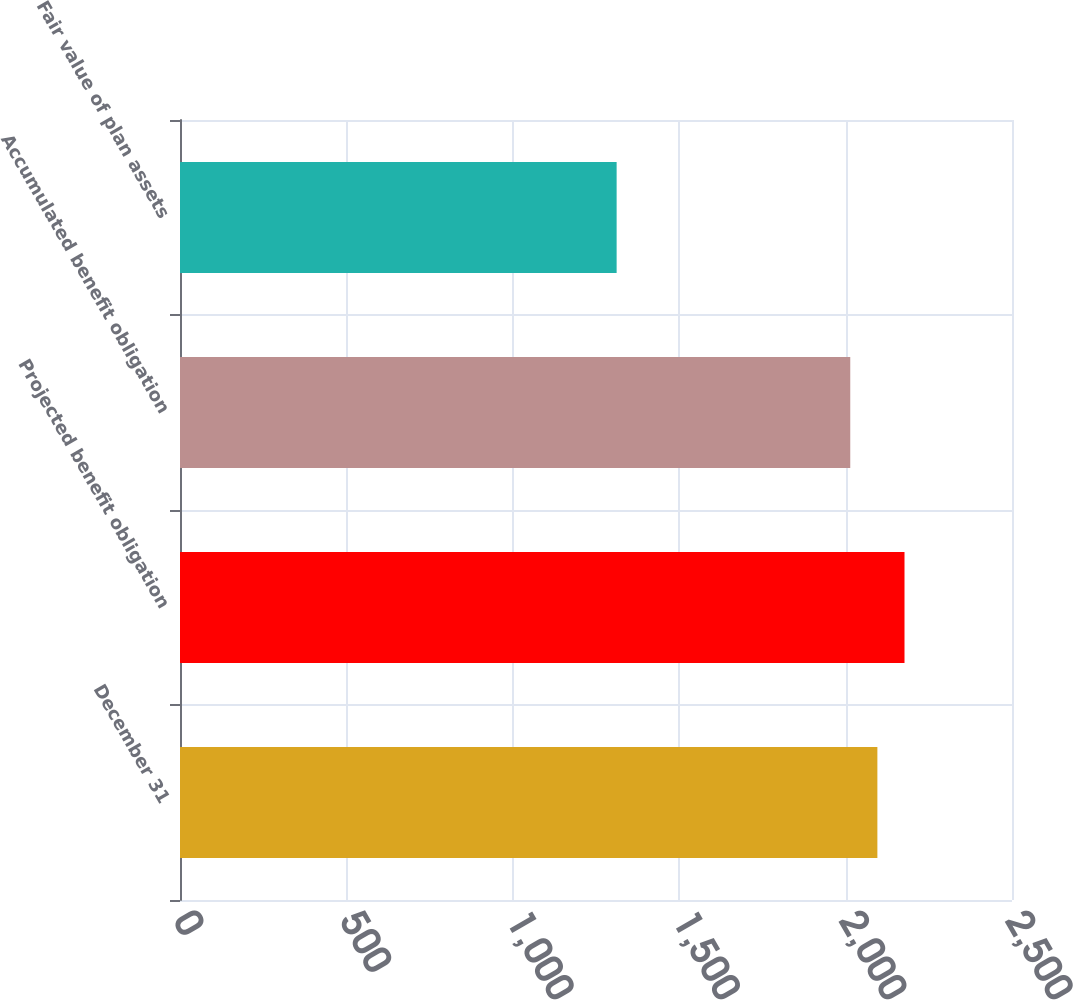Convert chart to OTSL. <chart><loc_0><loc_0><loc_500><loc_500><bar_chart><fcel>December 31<fcel>Projected benefit obligation<fcel>Accumulated benefit obligation<fcel>Fair value of plan assets<nl><fcel>2095.5<fcel>2177<fcel>2014<fcel>1312<nl></chart> 